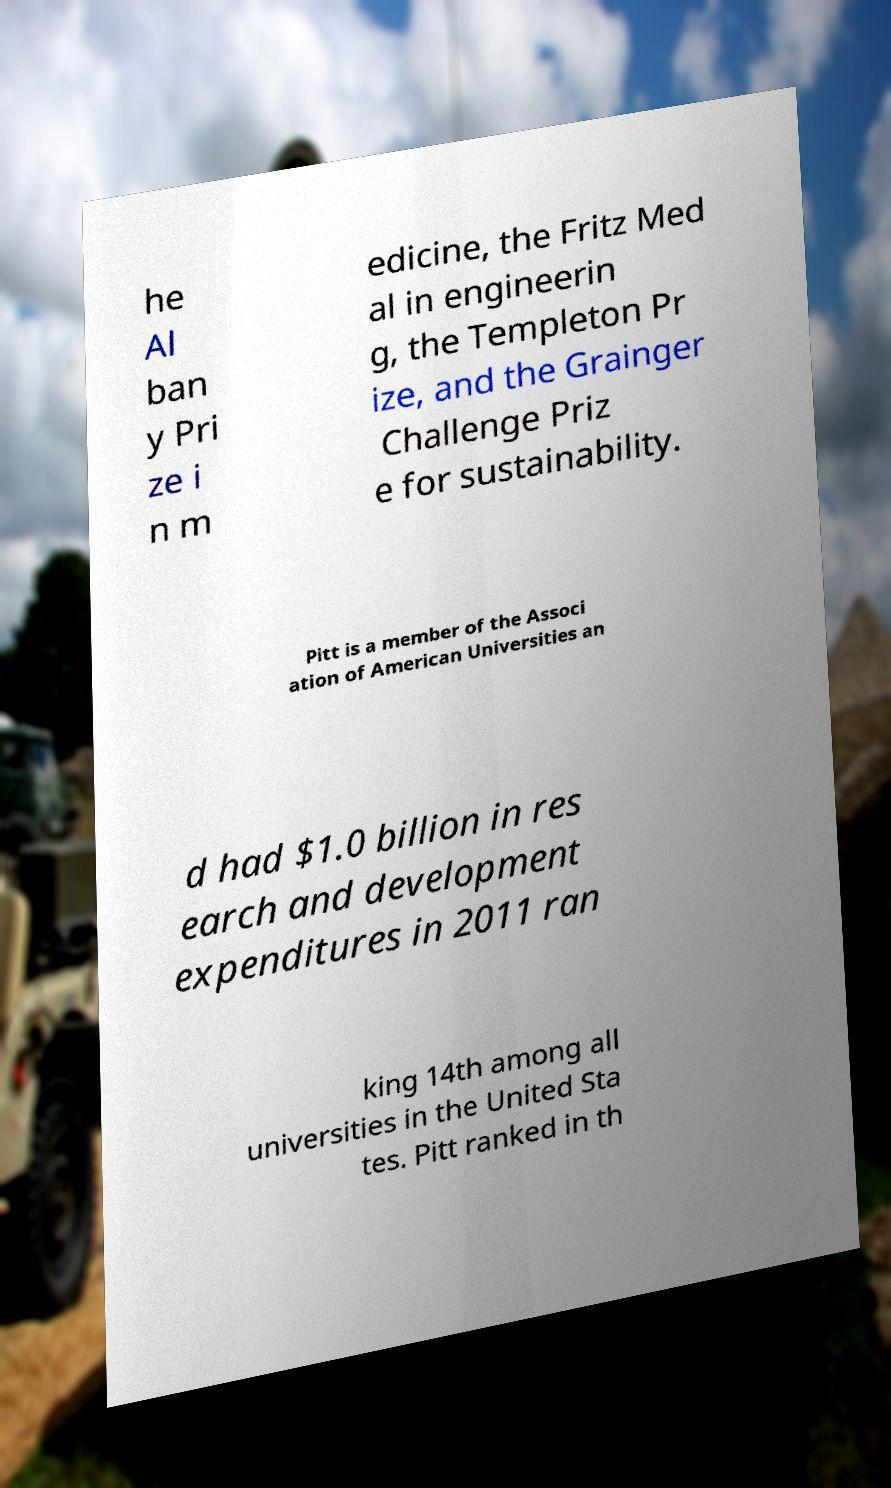For documentation purposes, I need the text within this image transcribed. Could you provide that? he Al ban y Pri ze i n m edicine, the Fritz Med al in engineerin g, the Templeton Pr ize, and the Grainger Challenge Priz e for sustainability. Pitt is a member of the Associ ation of American Universities an d had $1.0 billion in res earch and development expenditures in 2011 ran king 14th among all universities in the United Sta tes. Pitt ranked in th 